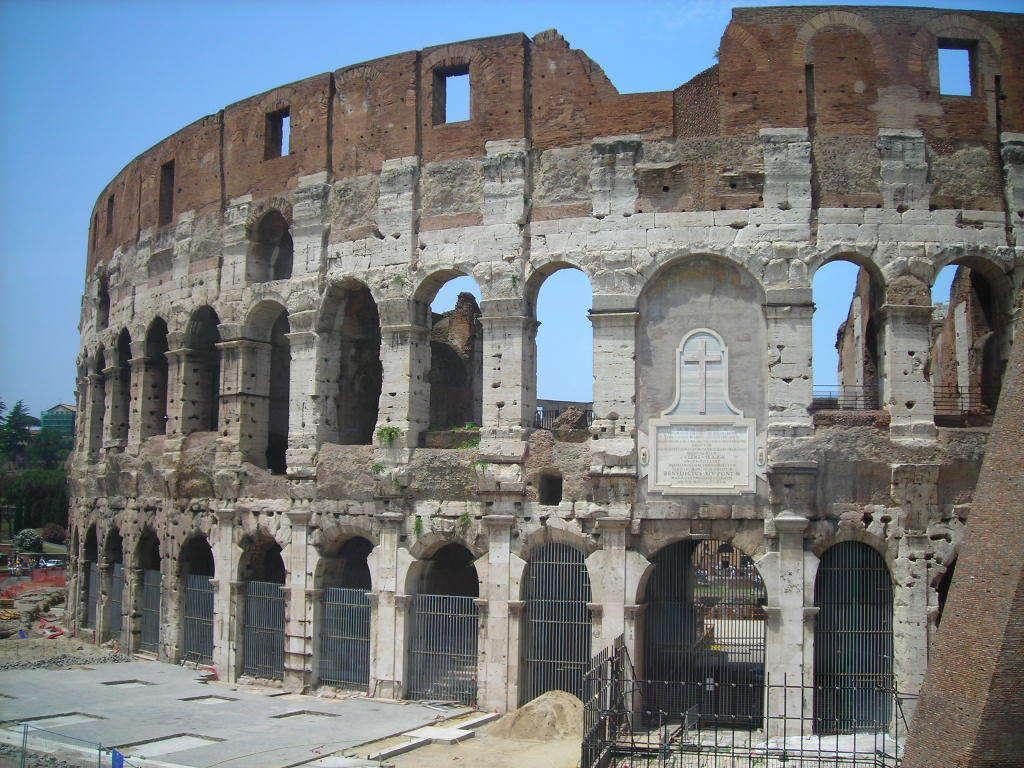What is the main structure in the center of the image? There is a colosseum in the center of the image. What type of vegetation is on the left side of the image? There are trees on the left side of the image. What is visible at the top of the image? The sky is visible at the top of the image. How many ladybugs can be seen on the colosseum in the image? There are no ladybugs present on the colosseum in the image. Is there a skateboarding ramp visible in the image? There is no skateboarding ramp present in the image. 